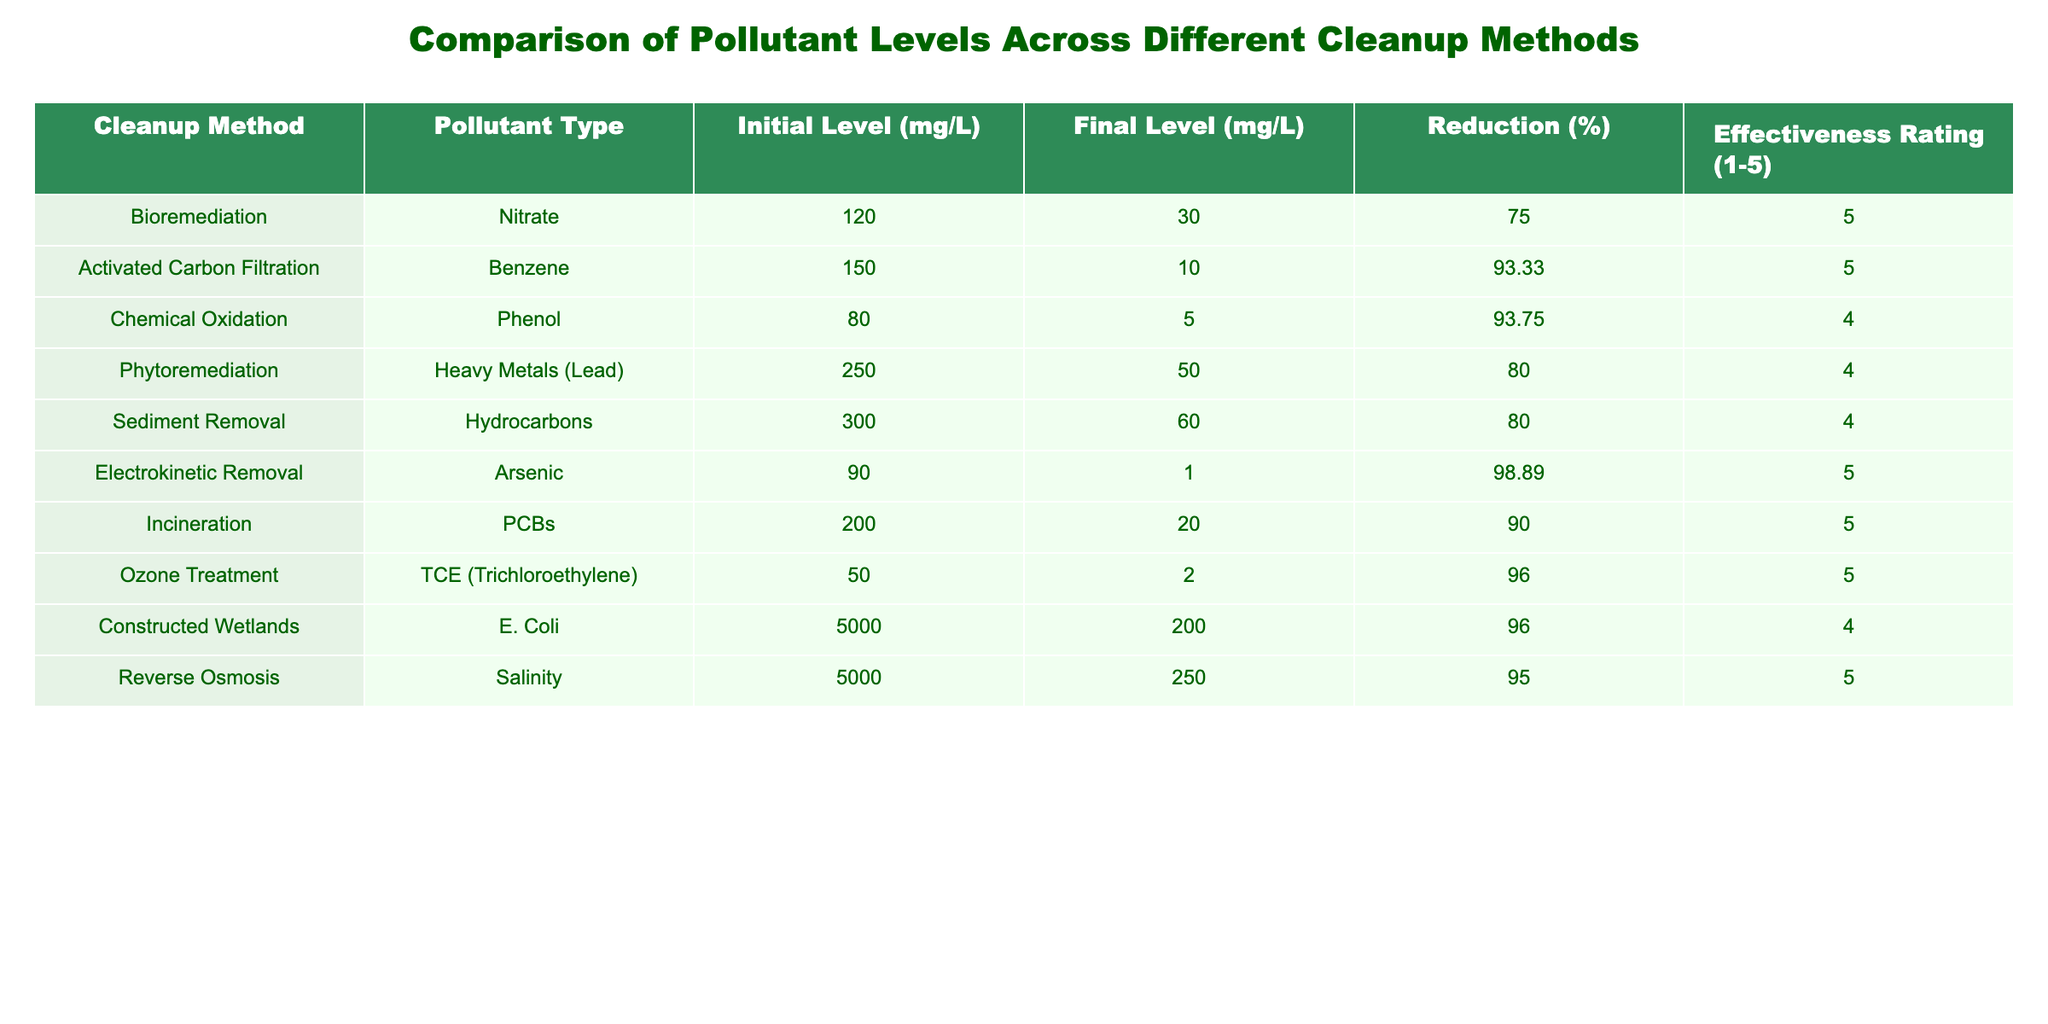What is the effectiveness rating of Chemical Oxidation? The effectiveness rating is listed in the "Effectiveness Rating" column for the "Chemical Oxidation" method, which is 4.
Answer: 4 Which cleanup method has the highest percentage reduction of pollutants? To find this, look at the "Reduction (%)" column. The "Electrokinetic Removal" method shows the highest reduction at 98.89%.
Answer: 98.89 What is the final level of Nitrate after Bioremediation? The final level of Nitrate after Bioremediation is provided in the "Final Level (mg/L)" column for that method, which is 30 mg/L.
Answer: 30 How many cleanup methods achieved an effectiveness rating of 5? Count the number of methods listed in the "Effectiveness Rating" column that have a rating of 5. There are four methods that have this rating.
Answer: 4 What is the average reduction percentage of all the cleanup methods listed? To calculate the average reduction percentage, sum the "Reduction (%)" values (75 + 93.33 + 93.75 + 80 + 80 + 98.89 + 90 + 96 + 96 + 95 = 905.86) and divide by 10 (the number of methods), resulting in 90.59%.
Answer: 90.59 Is the final level of Hydrocarbons after Sediment Removal lower than 100 mg/L? The final level of Hydrocarbons after Sediment Removal is mentioned in the "Final Level (mg/L)" column as 60 mg/L, which is indeed lower than 100 mg/L.
Answer: Yes What is the difference between the initial level of Salinity and the final level after Reverse Osmosis? The initial level of Salinity is 5000 mg/L and the final level is 250 mg/L. The difference is 5000 - 250 = 4750 mg/L.
Answer: 4750 Which methods were used for dealing with Benzene and TCE, and what is their effectiveness rating? Benzene was treated using "Activated Carbon Filtration" (rating 5), and TCE was treated using "Ozone Treatment" (rating 5). Both methods received an effectiveness rating of 5.
Answer: Both methods rated 5 What is the initial level of Heavy Metals (Lead) and what is the reduction percentage? The initial level of Heavy Metals (Lead) is 250 mg/L, and the reduction percentage for Phytoremediation (the method used) is 80%.
Answer: 250 mg/L, 80% 